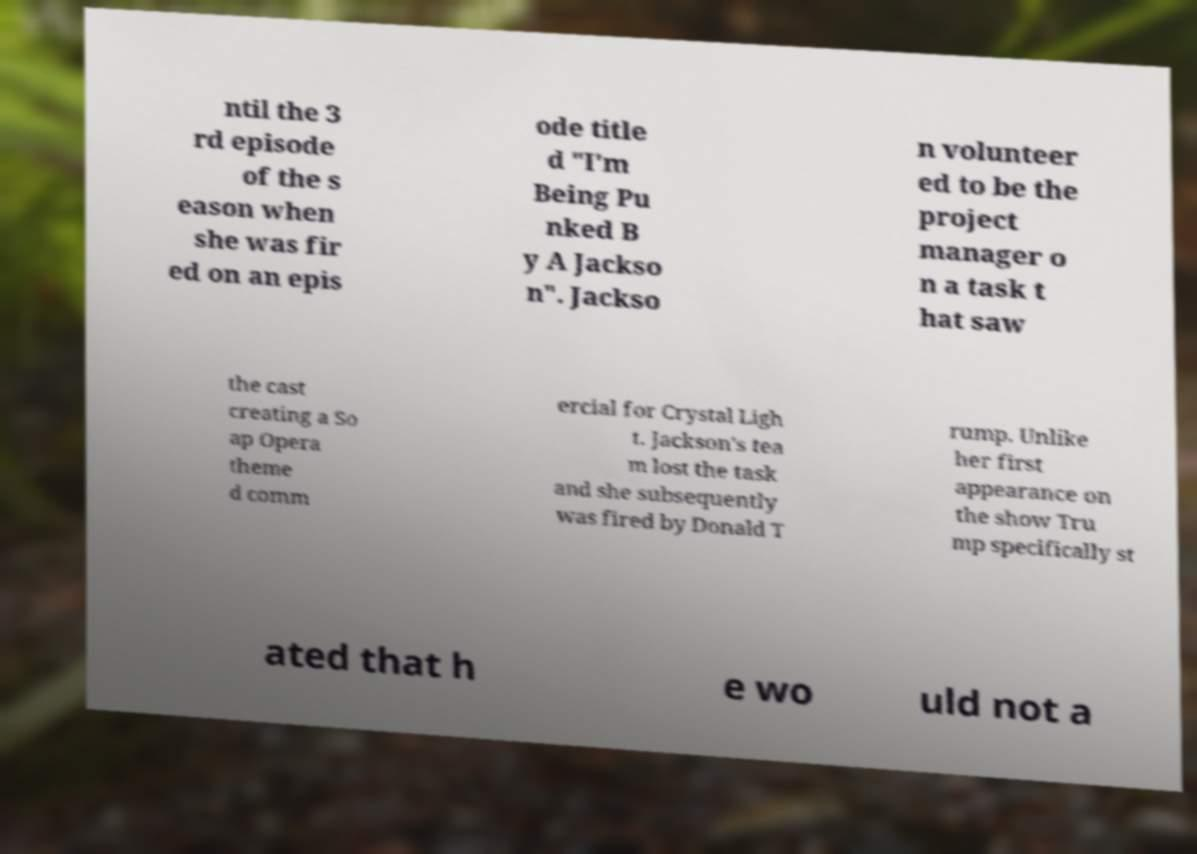Please read and relay the text visible in this image. What does it say? ntil the 3 rd episode of the s eason when she was fir ed on an epis ode title d "I'm Being Pu nked B y A Jackso n". Jackso n volunteer ed to be the project manager o n a task t hat saw the cast creating a So ap Opera theme d comm ercial for Crystal Ligh t. Jackson's tea m lost the task and she subsequently was fired by Donald T rump. Unlike her first appearance on the show Tru mp specifically st ated that h e wo uld not a 